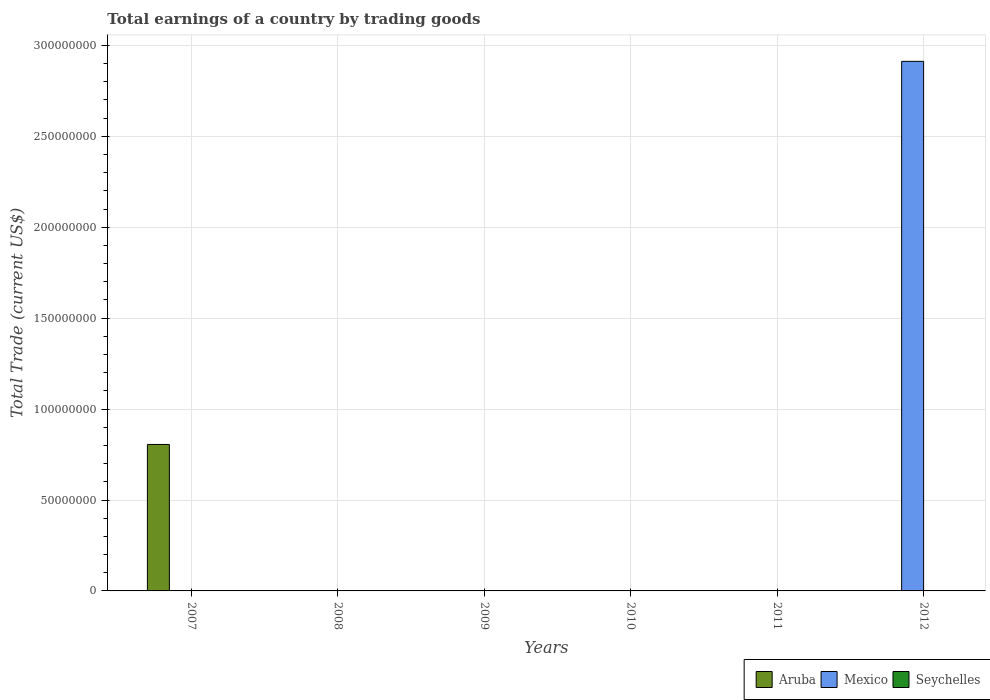How many different coloured bars are there?
Provide a short and direct response. 2. Are the number of bars on each tick of the X-axis equal?
Provide a succinct answer. No. How many bars are there on the 2nd tick from the left?
Provide a short and direct response. 0. How many bars are there on the 5th tick from the right?
Offer a very short reply. 0. What is the total earnings in Mexico in 2012?
Your answer should be compact. 2.91e+08. Across all years, what is the maximum total earnings in Aruba?
Ensure brevity in your answer.  8.06e+07. Across all years, what is the minimum total earnings in Mexico?
Your response must be concise. 0. In which year was the total earnings in Aruba maximum?
Ensure brevity in your answer.  2007. What is the total total earnings in Mexico in the graph?
Provide a short and direct response. 2.91e+08. What is the average total earnings in Seychelles per year?
Give a very brief answer. 0. In how many years, is the total earnings in Aruba greater than 110000000 US$?
Your answer should be compact. 0. What is the difference between the highest and the lowest total earnings in Mexico?
Your answer should be very brief. 2.91e+08. In how many years, is the total earnings in Aruba greater than the average total earnings in Aruba taken over all years?
Give a very brief answer. 1. Are all the bars in the graph horizontal?
Your answer should be compact. No. What is the difference between two consecutive major ticks on the Y-axis?
Make the answer very short. 5.00e+07. Are the values on the major ticks of Y-axis written in scientific E-notation?
Your answer should be very brief. No. Does the graph contain any zero values?
Keep it short and to the point. Yes. Where does the legend appear in the graph?
Make the answer very short. Bottom right. How many legend labels are there?
Give a very brief answer. 3. What is the title of the graph?
Give a very brief answer. Total earnings of a country by trading goods. What is the label or title of the X-axis?
Make the answer very short. Years. What is the label or title of the Y-axis?
Offer a very short reply. Total Trade (current US$). What is the Total Trade (current US$) of Aruba in 2007?
Offer a terse response. 8.06e+07. What is the Total Trade (current US$) of Mexico in 2007?
Ensure brevity in your answer.  0. What is the Total Trade (current US$) of Seychelles in 2007?
Provide a succinct answer. 0. What is the Total Trade (current US$) in Aruba in 2008?
Ensure brevity in your answer.  0. What is the Total Trade (current US$) of Mexico in 2008?
Provide a short and direct response. 0. What is the Total Trade (current US$) in Seychelles in 2009?
Keep it short and to the point. 0. What is the Total Trade (current US$) of Aruba in 2010?
Provide a short and direct response. 0. What is the Total Trade (current US$) in Mexico in 2010?
Ensure brevity in your answer.  0. What is the Total Trade (current US$) in Seychelles in 2010?
Offer a very short reply. 0. What is the Total Trade (current US$) of Mexico in 2012?
Offer a terse response. 2.91e+08. What is the Total Trade (current US$) in Seychelles in 2012?
Provide a short and direct response. 0. Across all years, what is the maximum Total Trade (current US$) in Aruba?
Offer a very short reply. 8.06e+07. Across all years, what is the maximum Total Trade (current US$) of Mexico?
Offer a very short reply. 2.91e+08. Across all years, what is the minimum Total Trade (current US$) of Mexico?
Offer a terse response. 0. What is the total Total Trade (current US$) of Aruba in the graph?
Provide a succinct answer. 8.06e+07. What is the total Total Trade (current US$) of Mexico in the graph?
Offer a very short reply. 2.91e+08. What is the difference between the Total Trade (current US$) of Aruba in 2007 and the Total Trade (current US$) of Mexico in 2012?
Give a very brief answer. -2.11e+08. What is the average Total Trade (current US$) in Aruba per year?
Provide a short and direct response. 1.34e+07. What is the average Total Trade (current US$) of Mexico per year?
Your answer should be compact. 4.85e+07. What is the difference between the highest and the lowest Total Trade (current US$) of Aruba?
Keep it short and to the point. 8.06e+07. What is the difference between the highest and the lowest Total Trade (current US$) of Mexico?
Keep it short and to the point. 2.91e+08. 